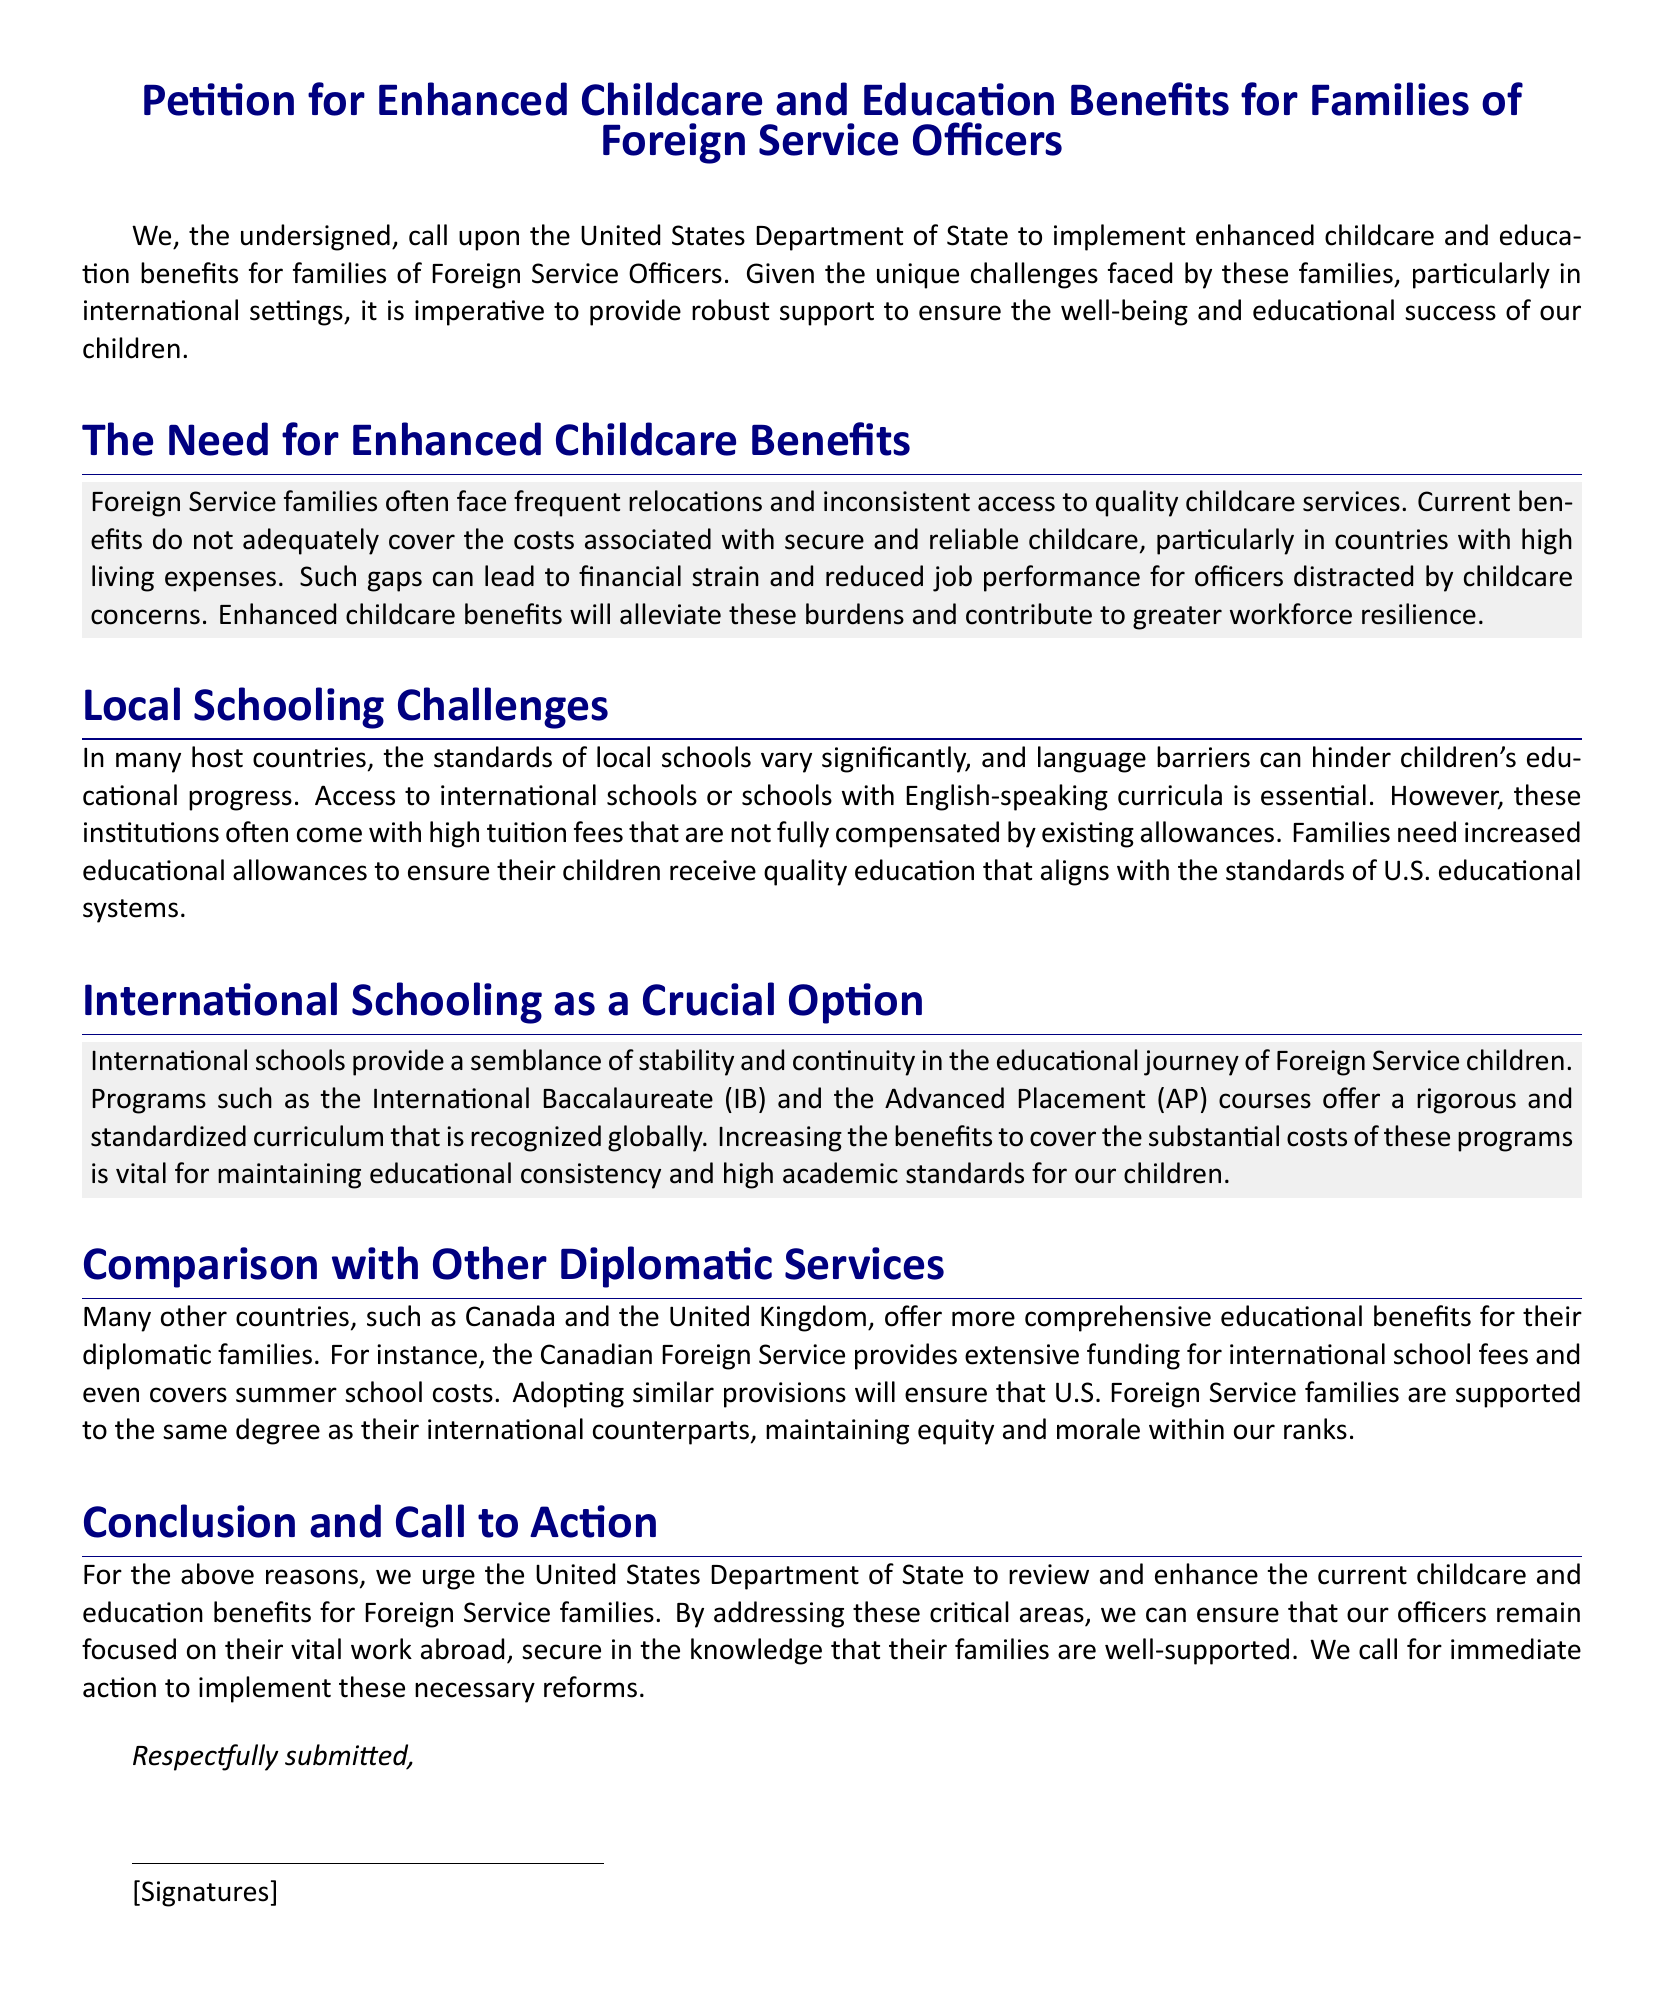What is the title of the petition? The title of the petition is stated at the top of the document.
Answer: Petition for Enhanced Childcare and Education Benefits for Families of Foreign Service Officers What department is being called upon? The petition specifically addresses a request to a particular government body.
Answer: United States Department of State What are families of Foreign Service Officers often faced with? The text describes unique challenges in a specific context.
Answer: Frequent relocations What benefits are families seeking to enhance? The main focus of the petition is on specific types of support for families.
Answer: Childcare and education benefits What program is mentioned for maintaining educational consistency? A specific academic program is highlighted in relation to the petition's goals.
Answer: International Baccalaureate (IB) Which countries are compared to the U.S. regarding educational benefits? The document references specific countries to illustrate a point.
Answer: Canada and the United Kingdom What type of barriers can hinder children's progress in local schools? The petition discusses challenges faced by children in educational settings abroad.
Answer: Language barriers What is the purpose of this petition? The intent behind submitting this document is clearly articulated.
Answer: To review and enhance childcare and education benefits What type of institutions often have high tuition fees? The document identifies a specific type of educational institution that poses financial challenges.
Answer: International schools 